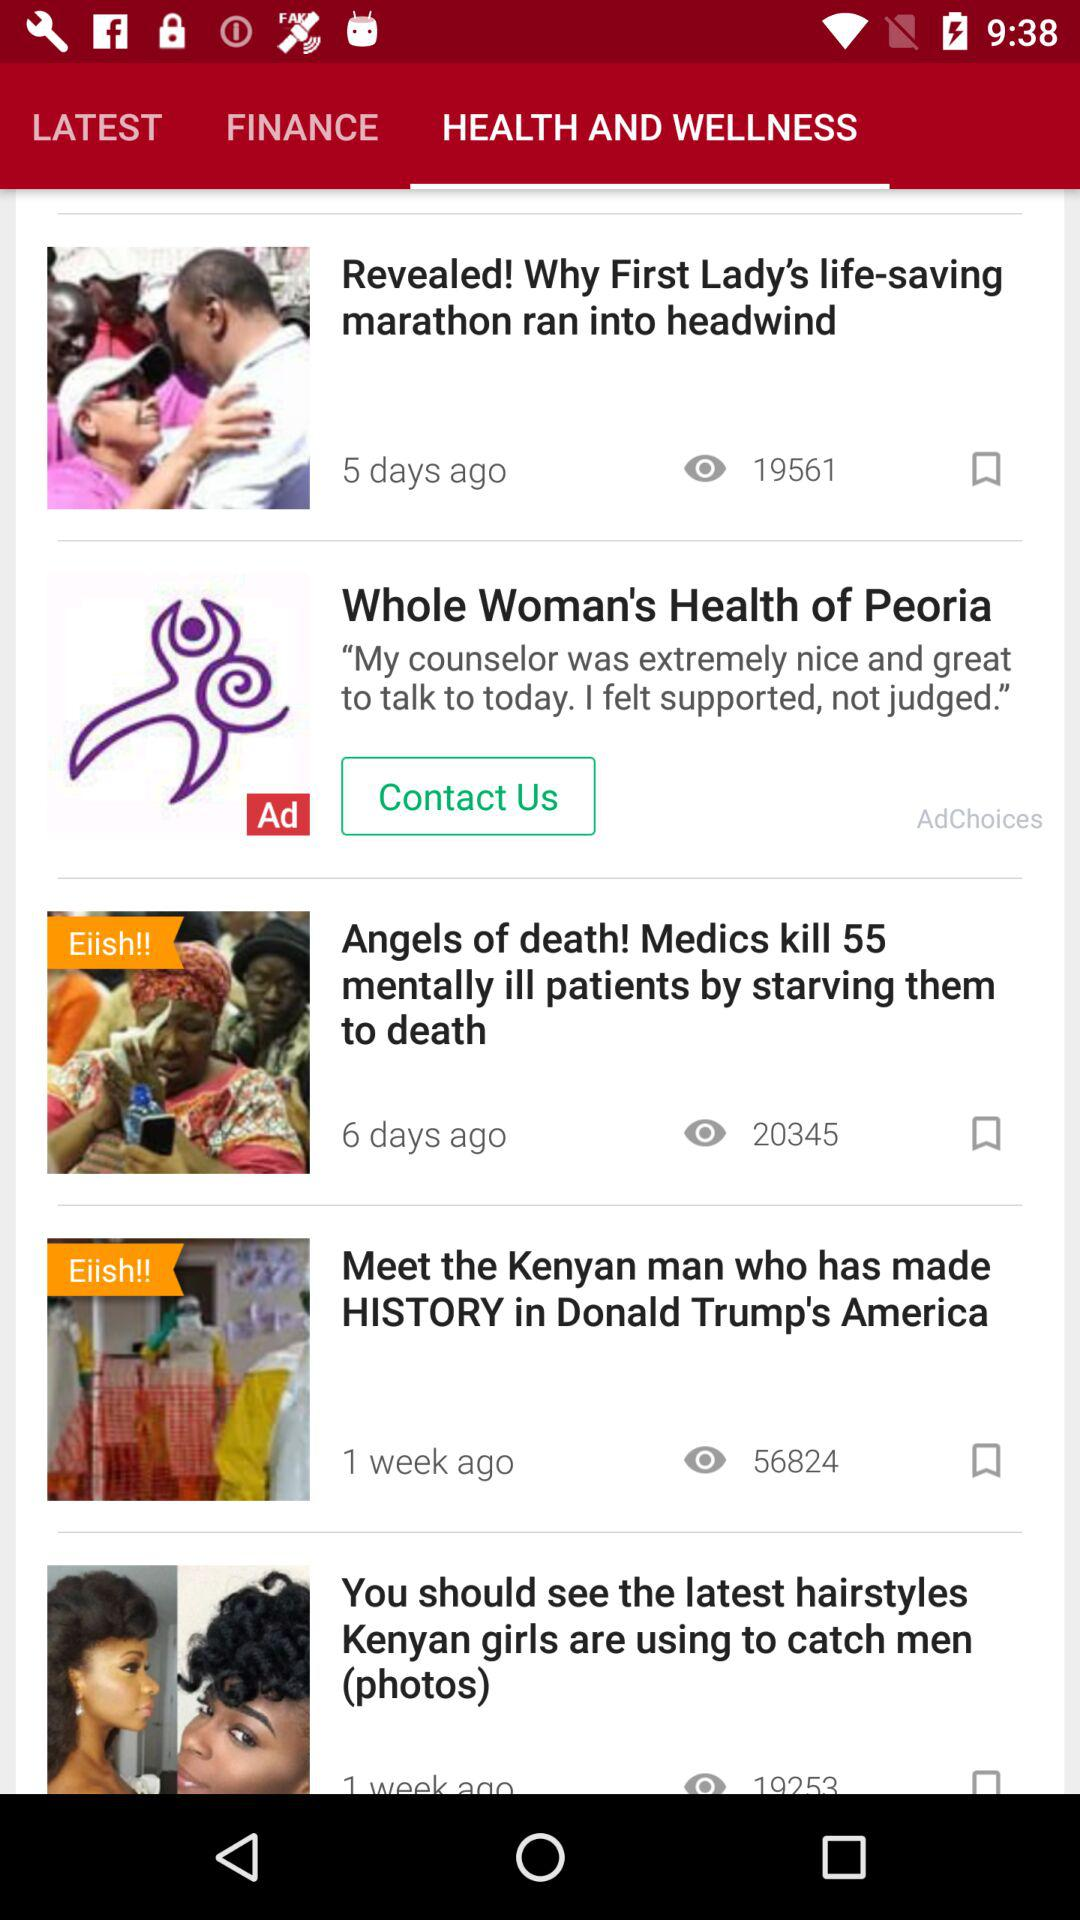How many more people viewed the article about the latest hairstyles Kenyan girls are using to catch men than the article about the Kenyan man who made history in Donald Trump's America?
Answer the question using a single word or phrase. 37571 